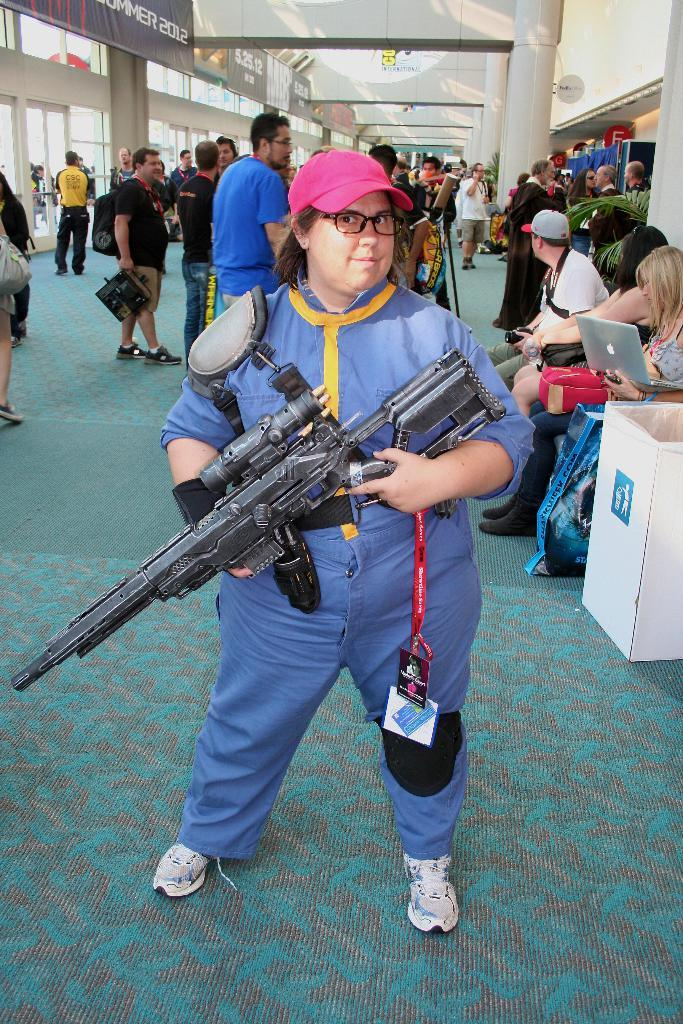What are the people in the image doing? Some people are standing on the floor, while others are sitting on chairs. What can be seen in the background of the image? There are house plants, advertisement boards, pillars, and glasses in the background. How does the power of the wind affect the people in the image? There is no wind or power mentioned in the image, so it cannot be determined how it would affect the people. 